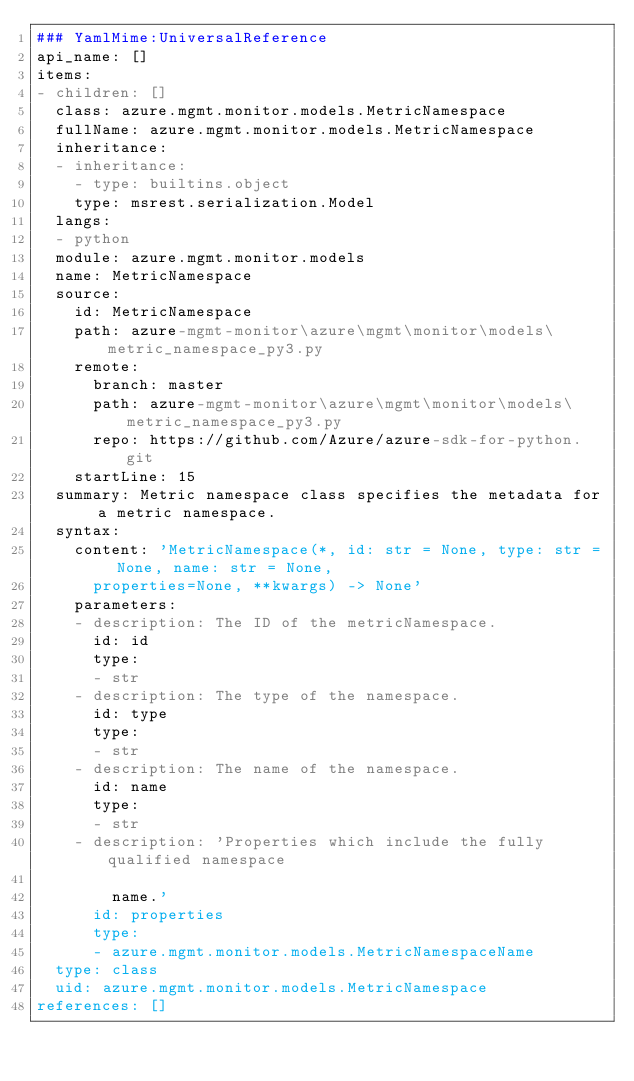Convert code to text. <code><loc_0><loc_0><loc_500><loc_500><_YAML_>### YamlMime:UniversalReference
api_name: []
items:
- children: []
  class: azure.mgmt.monitor.models.MetricNamespace
  fullName: azure.mgmt.monitor.models.MetricNamespace
  inheritance:
  - inheritance:
    - type: builtins.object
    type: msrest.serialization.Model
  langs:
  - python
  module: azure.mgmt.monitor.models
  name: MetricNamespace
  source:
    id: MetricNamespace
    path: azure-mgmt-monitor\azure\mgmt\monitor\models\metric_namespace_py3.py
    remote:
      branch: master
      path: azure-mgmt-monitor\azure\mgmt\monitor\models\metric_namespace_py3.py
      repo: https://github.com/Azure/azure-sdk-for-python.git
    startLine: 15
  summary: Metric namespace class specifies the metadata for a metric namespace.
  syntax:
    content: 'MetricNamespace(*, id: str = None, type: str = None, name: str = None,
      properties=None, **kwargs) -> None'
    parameters:
    - description: The ID of the metricNamespace.
      id: id
      type:
      - str
    - description: The type of the namespace.
      id: type
      type:
      - str
    - description: The name of the namespace.
      id: name
      type:
      - str
    - description: 'Properties which include the fully qualified namespace

        name.'
      id: properties
      type:
      - azure.mgmt.monitor.models.MetricNamespaceName
  type: class
  uid: azure.mgmt.monitor.models.MetricNamespace
references: []
</code> 